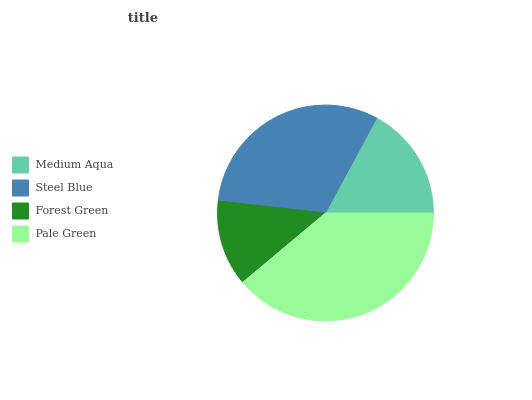Is Forest Green the minimum?
Answer yes or no. Yes. Is Pale Green the maximum?
Answer yes or no. Yes. Is Steel Blue the minimum?
Answer yes or no. No. Is Steel Blue the maximum?
Answer yes or no. No. Is Steel Blue greater than Medium Aqua?
Answer yes or no. Yes. Is Medium Aqua less than Steel Blue?
Answer yes or no. Yes. Is Medium Aqua greater than Steel Blue?
Answer yes or no. No. Is Steel Blue less than Medium Aqua?
Answer yes or no. No. Is Steel Blue the high median?
Answer yes or no. Yes. Is Medium Aqua the low median?
Answer yes or no. Yes. Is Medium Aqua the high median?
Answer yes or no. No. Is Forest Green the low median?
Answer yes or no. No. 